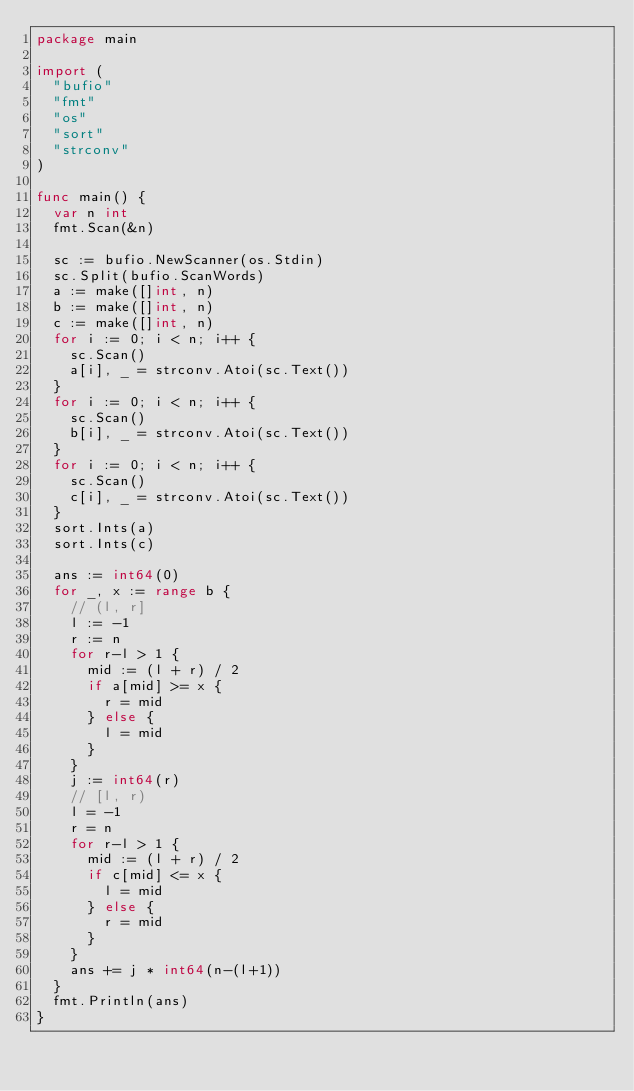Convert code to text. <code><loc_0><loc_0><loc_500><loc_500><_Go_>package main

import (
	"bufio"
	"fmt"
	"os"
	"sort"
	"strconv"
)

func main() {
	var n int
	fmt.Scan(&n)

	sc := bufio.NewScanner(os.Stdin)
	sc.Split(bufio.ScanWords)
	a := make([]int, n)
	b := make([]int, n)
	c := make([]int, n)
	for i := 0; i < n; i++ {
		sc.Scan()
		a[i], _ = strconv.Atoi(sc.Text())
	}
	for i := 0; i < n; i++ {
		sc.Scan()
		b[i], _ = strconv.Atoi(sc.Text())
	}
	for i := 0; i < n; i++ {
		sc.Scan()
		c[i], _ = strconv.Atoi(sc.Text())
	}
	sort.Ints(a)
	sort.Ints(c)

	ans := int64(0)
	for _, x := range b {
		// (l, r]
		l := -1
		r := n
		for r-l > 1 {
			mid := (l + r) / 2
			if a[mid] >= x {
				r = mid
			} else {
				l = mid
			}
		}
		j := int64(r)
		// [l, r)
		l = -1
		r = n
		for r-l > 1 {
			mid := (l + r) / 2
			if c[mid] <= x {
				l = mid
			} else {
				r = mid
			}
		}
		ans += j * int64(n-(l+1))
	}
	fmt.Println(ans)
}
</code> 